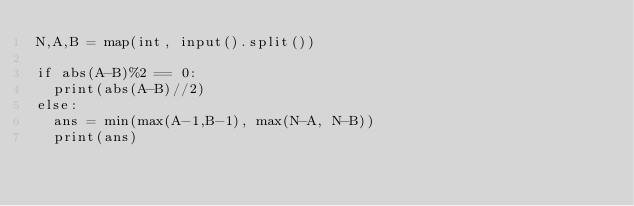<code> <loc_0><loc_0><loc_500><loc_500><_Python_>N,A,B = map(int, input().split())

if abs(A-B)%2 == 0:
	print(abs(A-B)//2)
else:
	ans = min(max(A-1,B-1), max(N-A, N-B))
	print(ans)</code> 